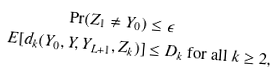Convert formula to latex. <formula><loc_0><loc_0><loc_500><loc_500>\Pr ( Z _ { 1 } \ne Y _ { 0 } ) & \leq \epsilon \\ E [ d _ { k } ( Y _ { 0 } , Y , Y _ { L + 1 } , Z _ { k } ) ] & \leq D _ { k } \ \text {for all $k \geq 2$} ,</formula> 